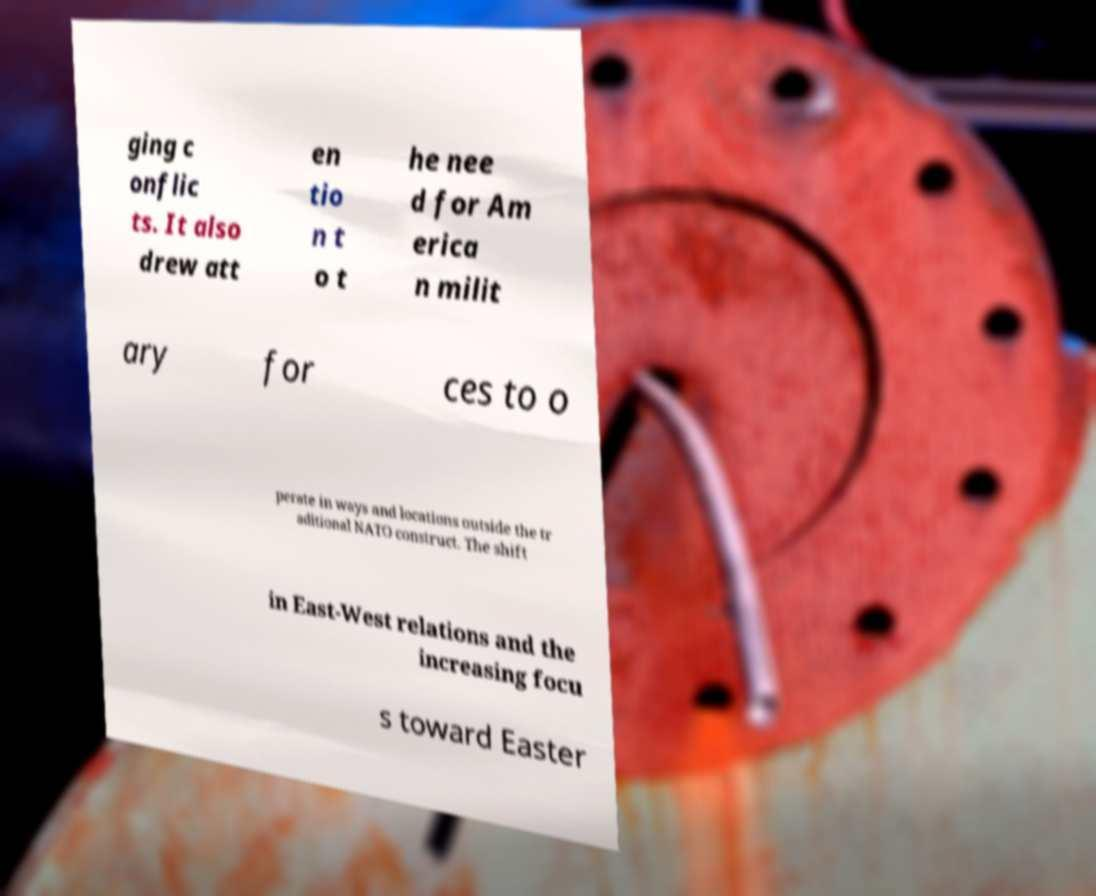For documentation purposes, I need the text within this image transcribed. Could you provide that? ging c onflic ts. It also drew att en tio n t o t he nee d for Am erica n milit ary for ces to o perate in ways and locations outside the tr aditional NATO construct. The shift in East-West relations and the increasing focu s toward Easter 